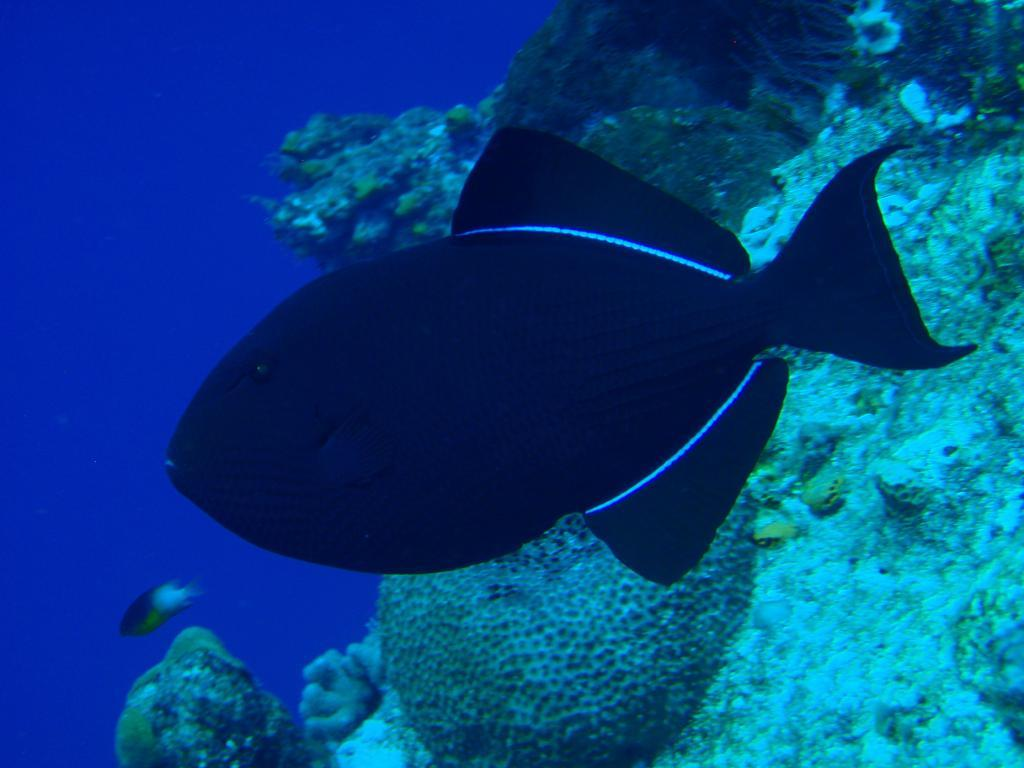What can be seen in the water in the foreground of the image? There are fish in the water in the foreground of the image. What else is visible in the background of the image? There appears to be a water plant in the right background of the image. What type of building can be seen in the image? There is no building present in the image; it features fish in the water and a water plant in the background. Can you describe the sidewalk in the image? There is no sidewalk present in the image. 